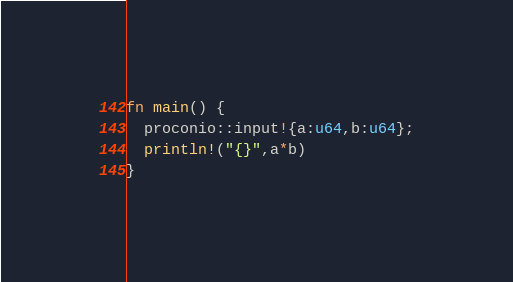Convert code to text. <code><loc_0><loc_0><loc_500><loc_500><_Rust_>fn main() {
  proconio::input!{a:u64,b:u64};
  println!("{}",a*b)
}</code> 